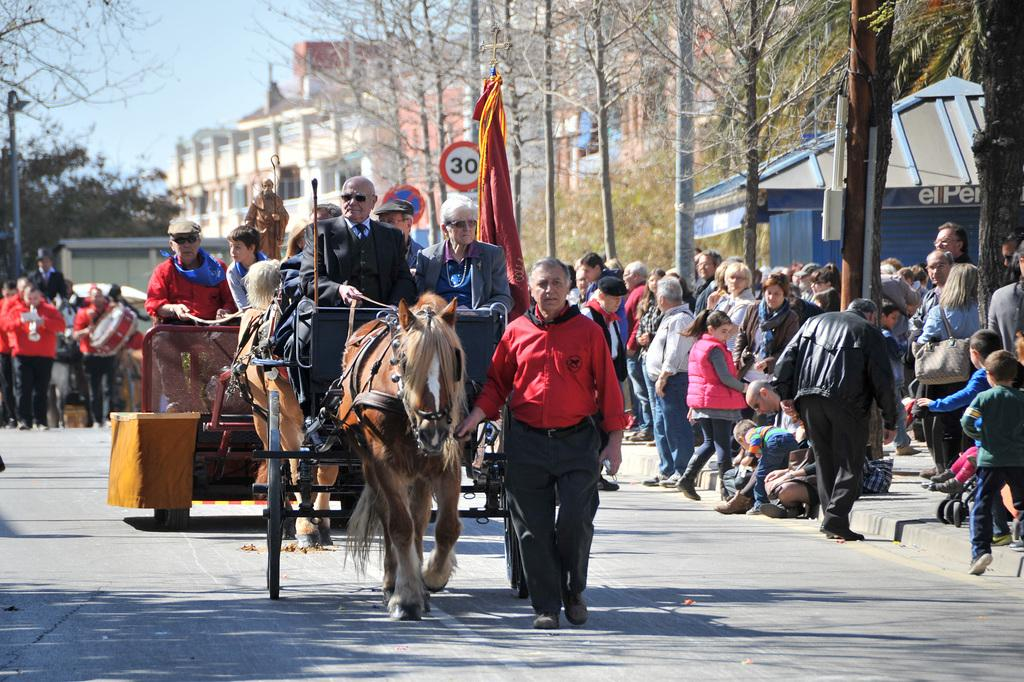What can be seen in the sky in the image? The sky is visible in the image, but no specific details about the sky are mentioned. What type of vegetation is present in the image? There are trees in the image. What type of structure is in the image? There is a building in the image. What type of artwork is in the image? There is a statue in the image. Who or what is present in the image? There are people in the image. What type of animal is in the image? There is a horse in the image. What is the price of the house in the image? There is no house present in the image, so it is not possible to determine the price. What type of coastline can be seen in the image? There is no coastline visible in the image. 